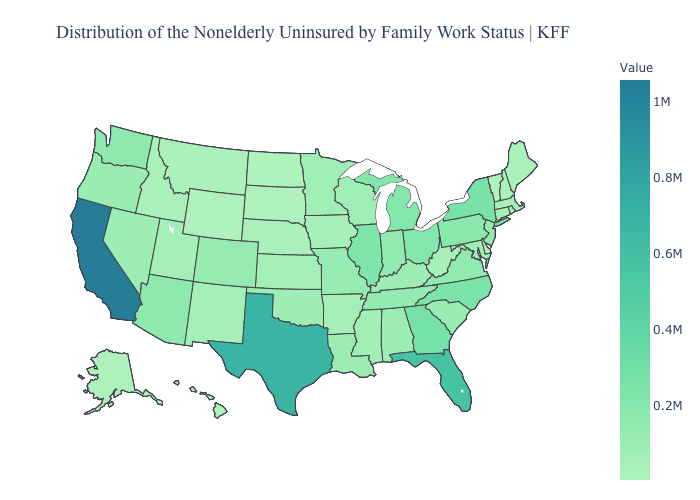Among the states that border Iowa , does Missouri have the highest value?
Concise answer only. No. Which states have the lowest value in the USA?
Give a very brief answer. Vermont. Is the legend a continuous bar?
Keep it brief. Yes. Does Arizona have a lower value than Kansas?
Quick response, please. No. Does California have the highest value in the USA?
Write a very short answer. Yes. Does California have the highest value in the USA?
Give a very brief answer. Yes. 